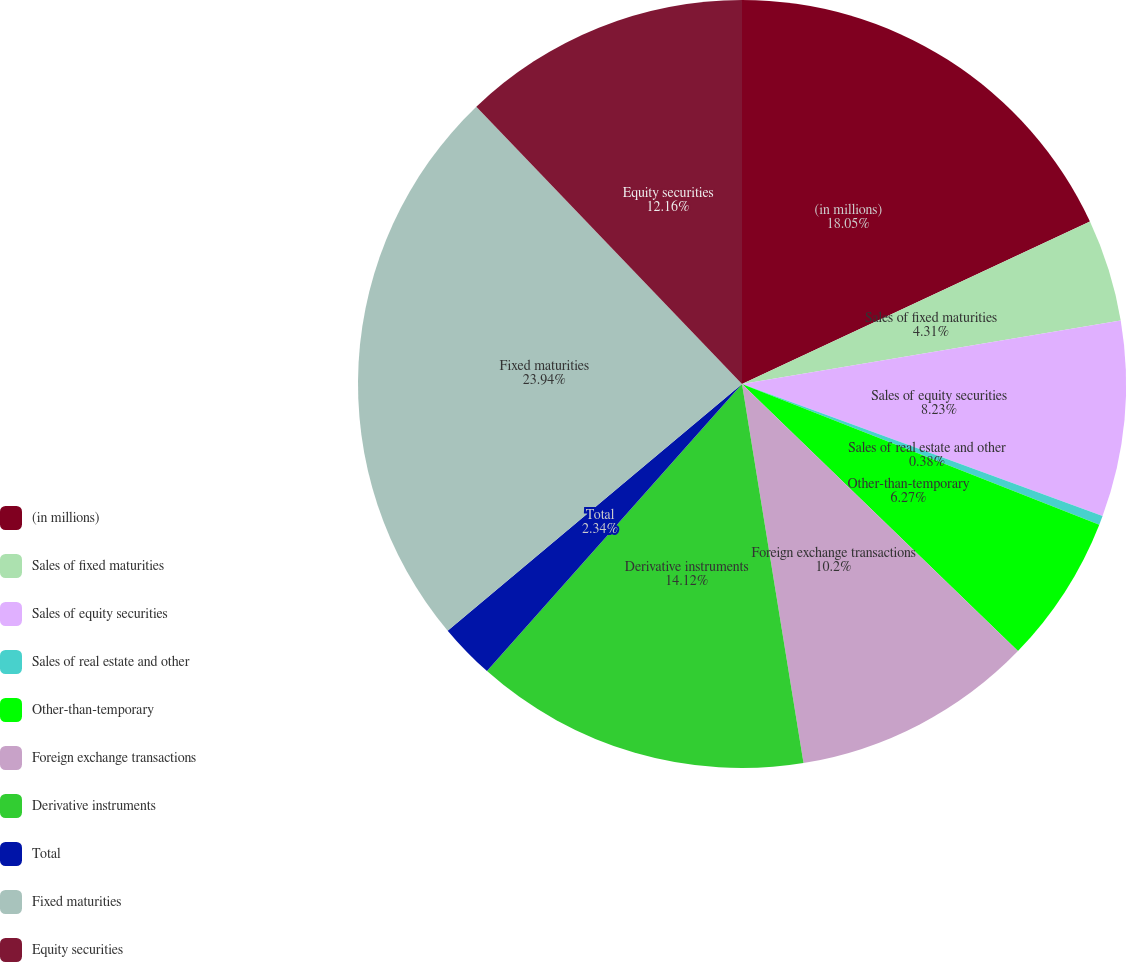Convert chart to OTSL. <chart><loc_0><loc_0><loc_500><loc_500><pie_chart><fcel>(in millions)<fcel>Sales of fixed maturities<fcel>Sales of equity securities<fcel>Sales of real estate and other<fcel>Other-than-temporary<fcel>Foreign exchange transactions<fcel>Derivative instruments<fcel>Total<fcel>Fixed maturities<fcel>Equity securities<nl><fcel>18.05%<fcel>4.31%<fcel>8.23%<fcel>0.38%<fcel>6.27%<fcel>10.2%<fcel>14.12%<fcel>2.34%<fcel>23.94%<fcel>12.16%<nl></chart> 